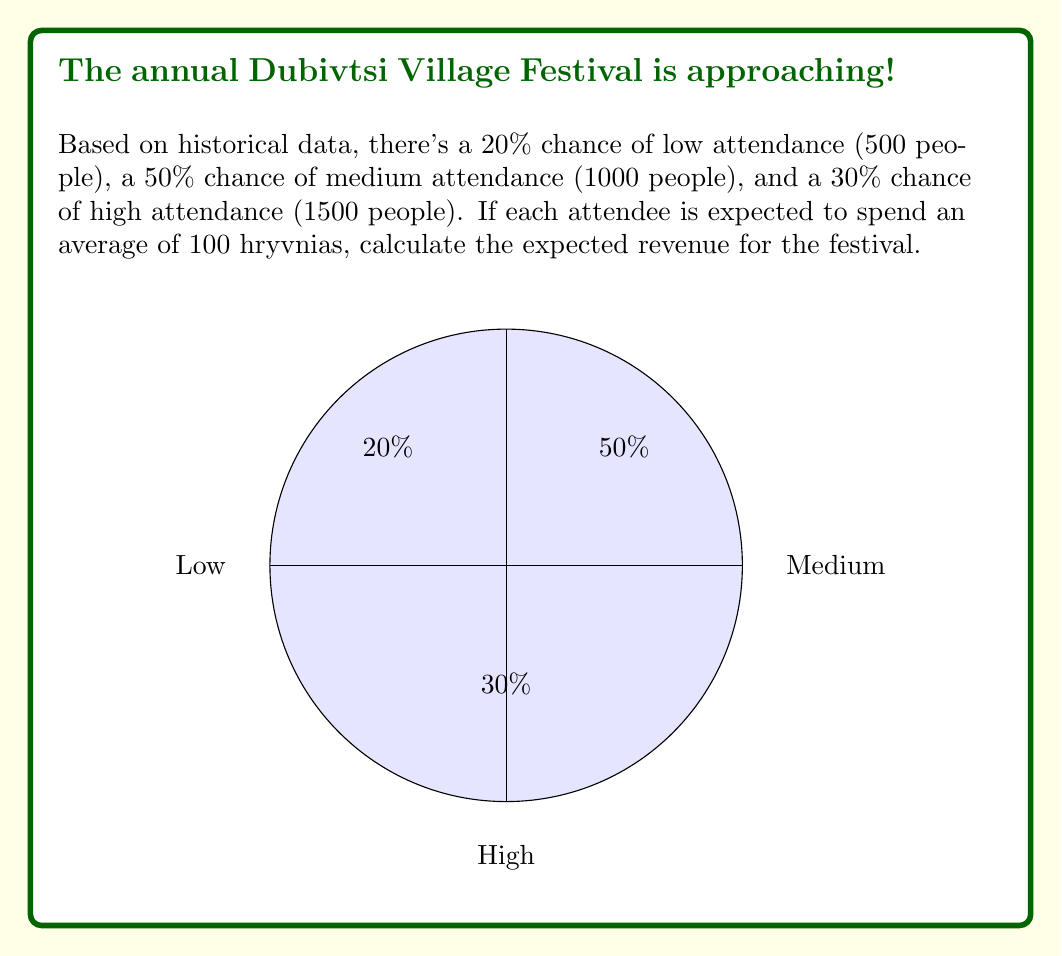Give your solution to this math problem. Let's approach this step-by-step using the concept of expected value:

1) First, let's define our random variable X as the revenue from the festival.

2) We have three possible outcomes:
   - Low attendance: 500 people
   - Medium attendance: 1000 people
   - High attendance: 1500 people

3) For each outcome, we can calculate the revenue:
   - Low: 500 * 100 = 50,000 hryvnias
   - Medium: 1000 * 100 = 100,000 hryvnias
   - High: 1500 * 100 = 150,000 hryvnias

4) The probabilities for each outcome are:
   - P(Low) = 0.20
   - P(Medium) = 0.50
   - P(High) = 0.30

5) The expected value is calculated by multiplying each possible outcome by its probability and then summing these products:

   $$E(X) = \sum_{i=1}^{n} x_i \cdot p(x_i)$$

   Where $x_i$ are the possible outcomes and $p(x_i)$ are their respective probabilities.

6) Plugging in our values:

   $$E(X) = 50,000 \cdot 0.20 + 100,000 \cdot 0.50 + 150,000 \cdot 0.30$$

7) Calculating:

   $$E(X) = 10,000 + 50,000 + 45,000 = 105,000$$

Therefore, the expected revenue for the Dubivtsi Village Festival is 105,000 hryvnias.
Answer: 105,000 hryvnias 